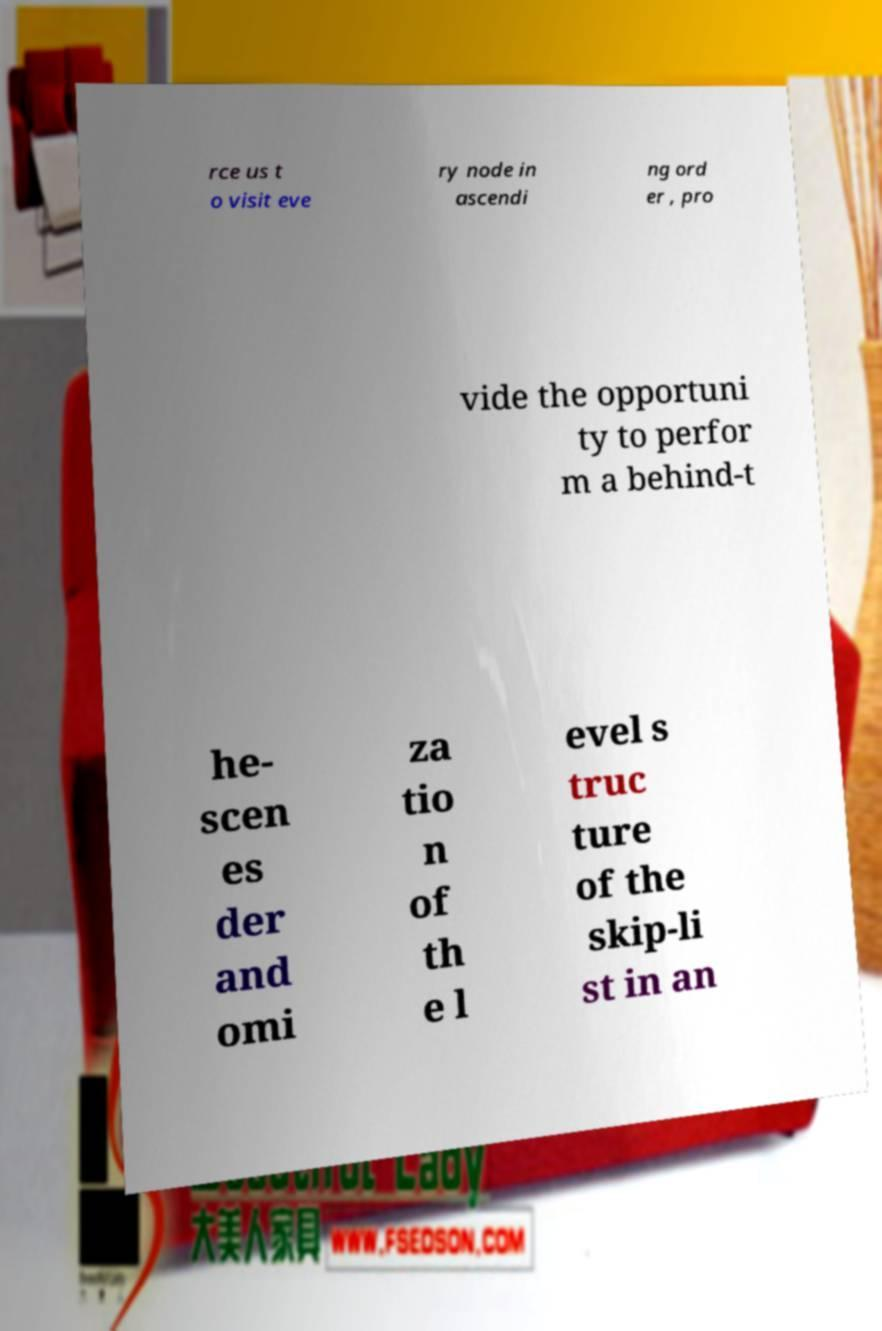There's text embedded in this image that I need extracted. Can you transcribe it verbatim? rce us t o visit eve ry node in ascendi ng ord er , pro vide the opportuni ty to perfor m a behind-t he- scen es der and omi za tio n of th e l evel s truc ture of the skip-li st in an 